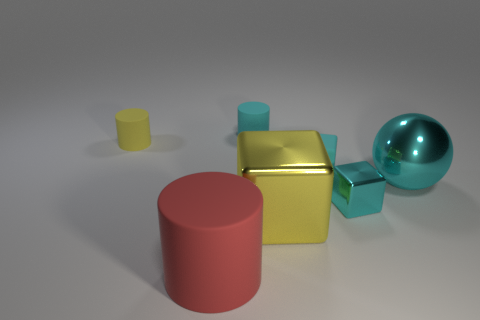Subtract all cyan blocks. How many were subtracted if there are1cyan blocks left? 1 Subtract all brown cylinders. How many cyan blocks are left? 2 Subtract all rubber blocks. How many blocks are left? 2 Add 1 small cyan matte things. How many objects exist? 8 Subtract all cyan cubes. How many cubes are left? 1 Subtract 1 blocks. How many blocks are left? 2 Add 5 big matte objects. How many big matte objects are left? 6 Add 1 yellow shiny cubes. How many yellow shiny cubes exist? 2 Subtract 0 blue balls. How many objects are left? 7 Subtract all spheres. How many objects are left? 6 